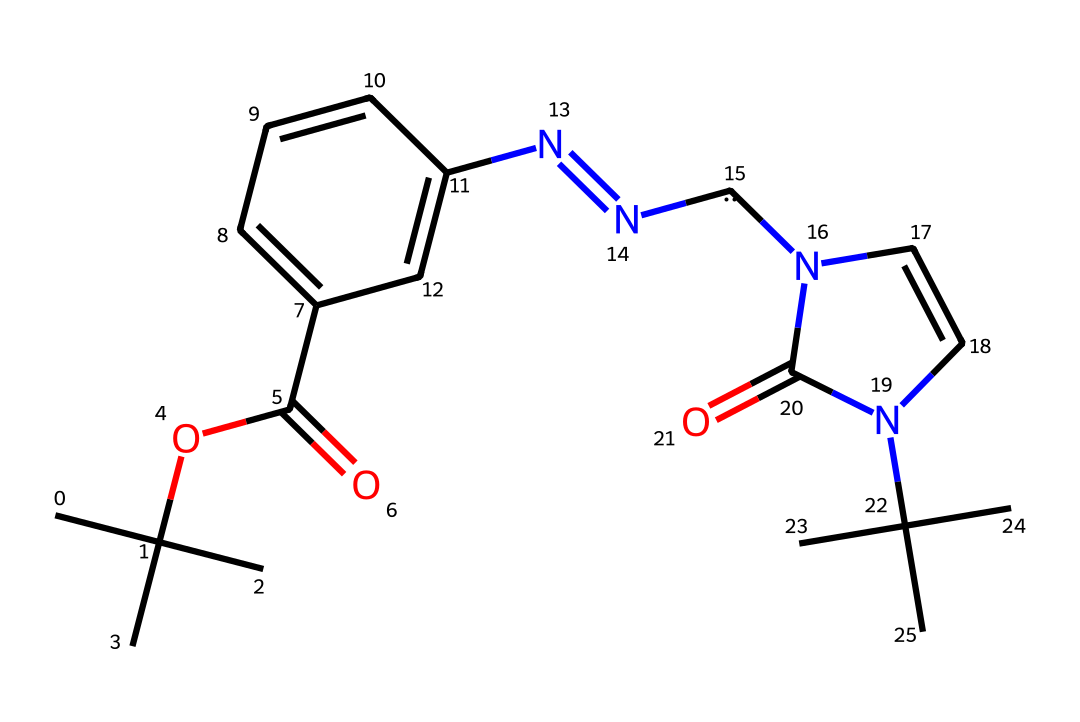What is the total number of carbon atoms in this molecule? By examining the structure, each vertex and endpoint in the SMILES representation typically indicates a carbon atom. Counting them carefully results in a total of 18 carbon atoms.
Answer: 18 What functional groups are present in the chemical? The structure contains an ester group (indicated by the OC(=O) part) and a hydrazone (N=N) functional group, both of which can be identified in the SMILES string.
Answer: ester and hydrazone How many nitrogen atoms are there in this molecule? By scanning the SMILES representation for the letter 'N,' we find three instances, indicating there are three nitrogen atoms in total.
Answer: 3 What unique feature in this structure indicates the presence of a carbene? The presence of a carbon atom that is bonded to two other groups through double bonds (specifically in the N=N part leading to [C]) indicates a carbene, which requires a divalent carbon atom that can participate in multiple bonding scenarios.
Answer: divalent carbon How does the structural configuration enhance flexibility in electronic devices? The branching alkyl groups (CC(C)(C)) and the unique backbone of the polymer are designed to improve mechanical properties, allowing for better flexibility in polymeric materials used in electronics.
Answer: branching alkyl groups What role does the nitrogen component play in enhancing educational technologies? The presence of nitrogen often contributes to the electronic properties of polymers, potentially enhancing conductivity and performance in flexible electronic applications for educational technologies.
Answer: conductivity 